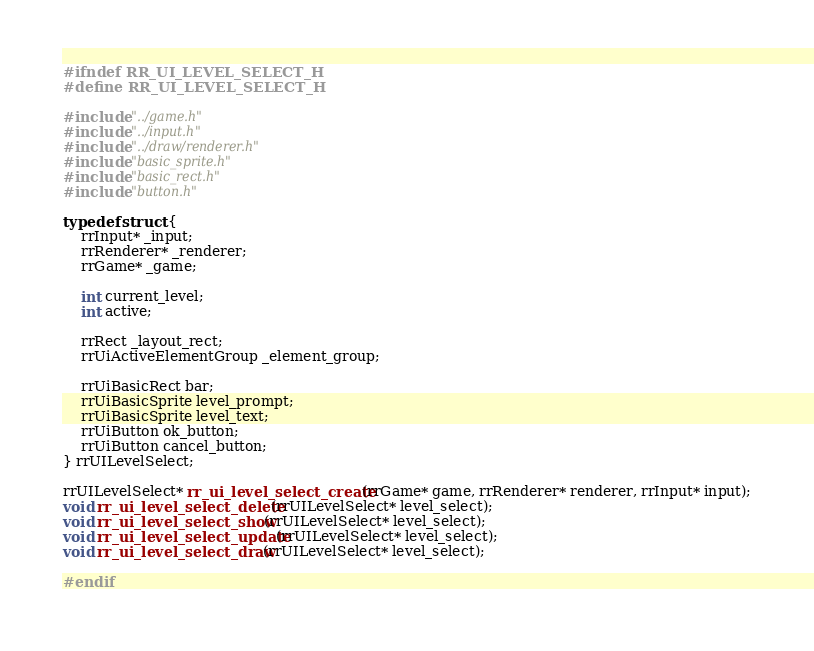<code> <loc_0><loc_0><loc_500><loc_500><_C_>#ifndef RR_UI_LEVEL_SELECT_H
#define RR_UI_LEVEL_SELECT_H

#include "../game.h"
#include "../input.h"
#include "../draw/renderer.h"
#include "basic_sprite.h"
#include "basic_rect.h"
#include "button.h"

typedef struct {
    rrInput* _input;
    rrRenderer* _renderer;
    rrGame* _game;

    int current_level;
    int active;

    rrRect _layout_rect;
    rrUiActiveElementGroup _element_group;

    rrUiBasicRect bar;
    rrUiBasicSprite level_prompt;
    rrUiBasicSprite level_text;
    rrUiButton ok_button;
    rrUiButton cancel_button;
} rrUILevelSelect;

rrUILevelSelect* rr_ui_level_select_create(rrGame* game, rrRenderer* renderer, rrInput* input);
void rr_ui_level_select_delete(rrUILevelSelect* level_select);
void rr_ui_level_select_show(rrUILevelSelect* level_select);
void rr_ui_level_select_update(rrUILevelSelect* level_select);
void rr_ui_level_select_draw(rrUILevelSelect* level_select);

#endif
</code> 